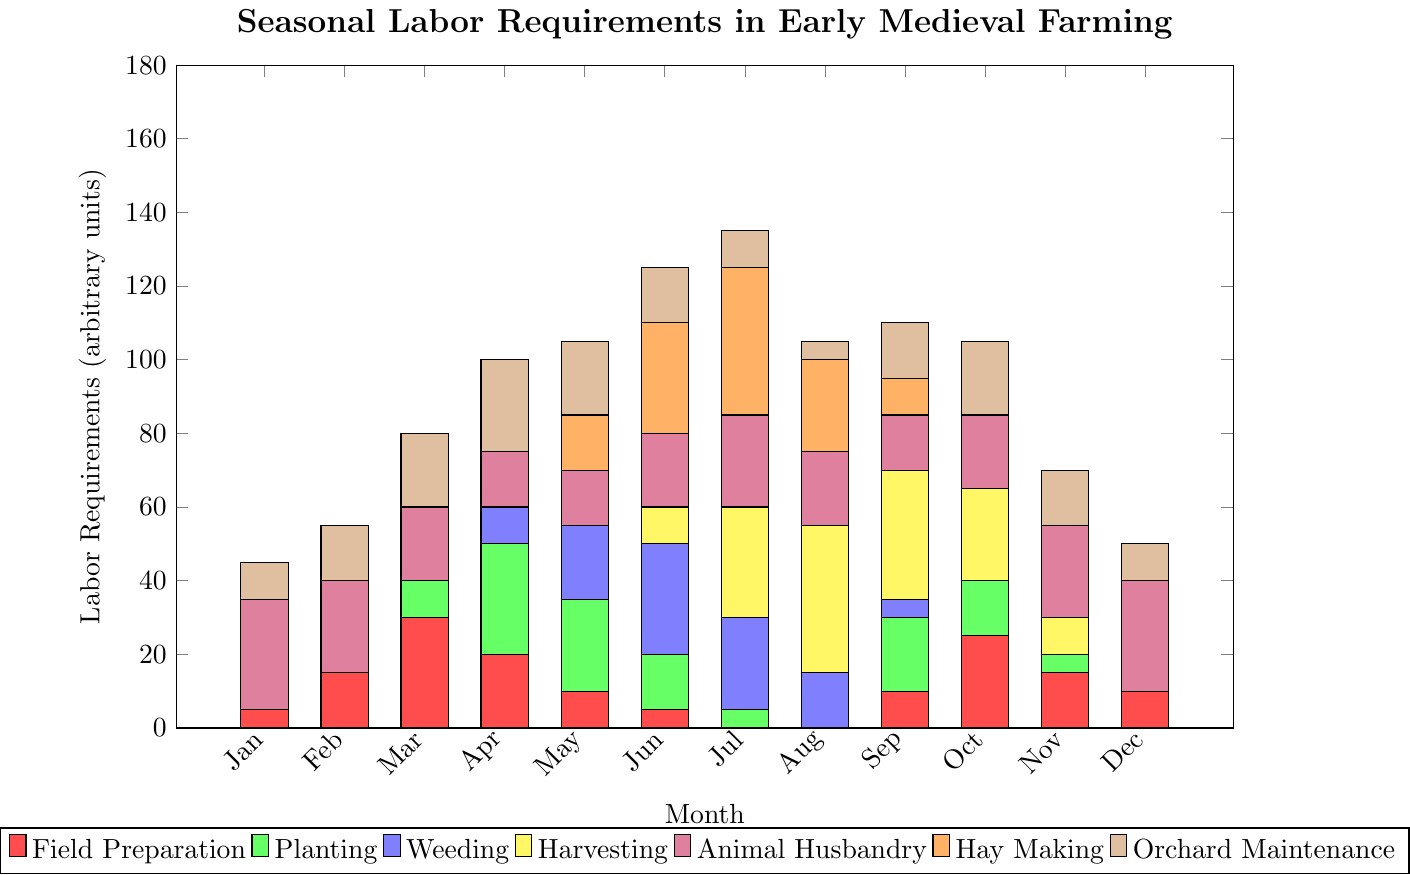Which month has the highest total labor requirement? To determine the month with the highest total labor requirement, sum the values for all activities in each month and compare. July has the highest total: 0 (Field Preparation) + 5 (Planting) + 25 (Weeding) + 30 (Harvesting) + 25 (Animal Husbandry) + 40 (Hay Making) + 10 (Orchard Maintenance) = 135.
Answer: July Which activity requires the most labor in June? To find out which activity requires the most labor in June, compare the values for each activity listed for June. Hay Making has the highest value at 30.
Answer: Hay Making How does the labor requirement for Harvesting change from June to August? To examine the change, note the value for Harvesting in June (10) and August (40). The change is 40 - 10 = 30, so there is an increase of 30 units.
Answer: Increases by 30 Which month has the least labor requirement for Field Preparation? Compare the values for Field Preparation across all months. July and August both have a value of 0 for Field Preparation, which is the lowest.
Answer: July and August What is the total labor requirement for Animal Husbandry in January, February, and December combined? Sum the values for Animal Husbandry in January (30), February (25), and December (30). The total is 30 + 25 + 30 = 85.
Answer: 85 Between April and October, in which month is the labor requirement for Weeding higher? Compare the values for Weeding in April (10) and October (0). April has a higher labor requirement for Weeding.
Answer: April What is the average labor requirement for Orchard Maintenance from March to May? Sum the values for Orchard Maintenance in March (20), April (25), and May (20), then divide by 3. The total is 20 + 25 + 20 = 65, and the average is 65 / 3 ≈ 21.67.
Answer: Approximately 21.67 Which activity has a higher labor requirement in September: Planting or Weeding? Compare the values for Planting (20) and Weeding (5) in September. Planting has a higher labor requirement.
Answer: Planting What is the total labor requirement for all activities in December? Sum the values for all activities in December: 10 (Field Preparation) + 0 (Planting) + 0 (Weeding) + 0 (Harvesting) + 30 (Animal Husbandry) + 0 (Hay Making) + 10 (Orchard Maintenance) = 50.
Answer: 50 